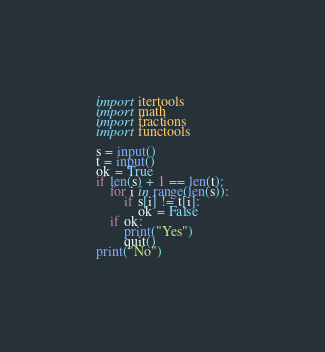Convert code to text. <code><loc_0><loc_0><loc_500><loc_500><_Python_>import itertools
import math
import fractions
import functools

s = input()
t = input()
ok = True
if len(s) + 1 == len(t):
    for i in range(len(s)):
        if s[i] != t[i]:
            ok = False
    if ok:
        print("Yes")
        quit()
print("No")</code> 